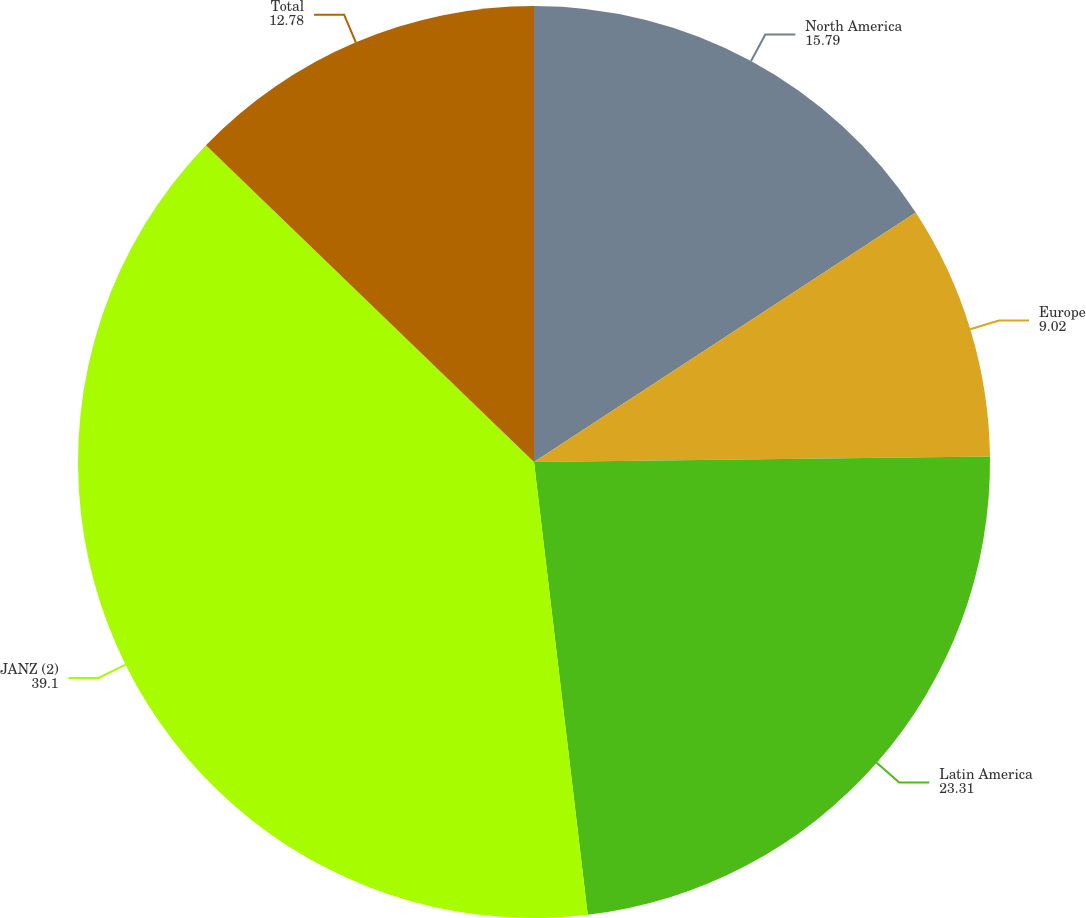Convert chart. <chart><loc_0><loc_0><loc_500><loc_500><pie_chart><fcel>North America<fcel>Europe<fcel>Latin America<fcel>JANZ (2)<fcel>Total<nl><fcel>15.79%<fcel>9.02%<fcel>23.31%<fcel>39.1%<fcel>12.78%<nl></chart> 